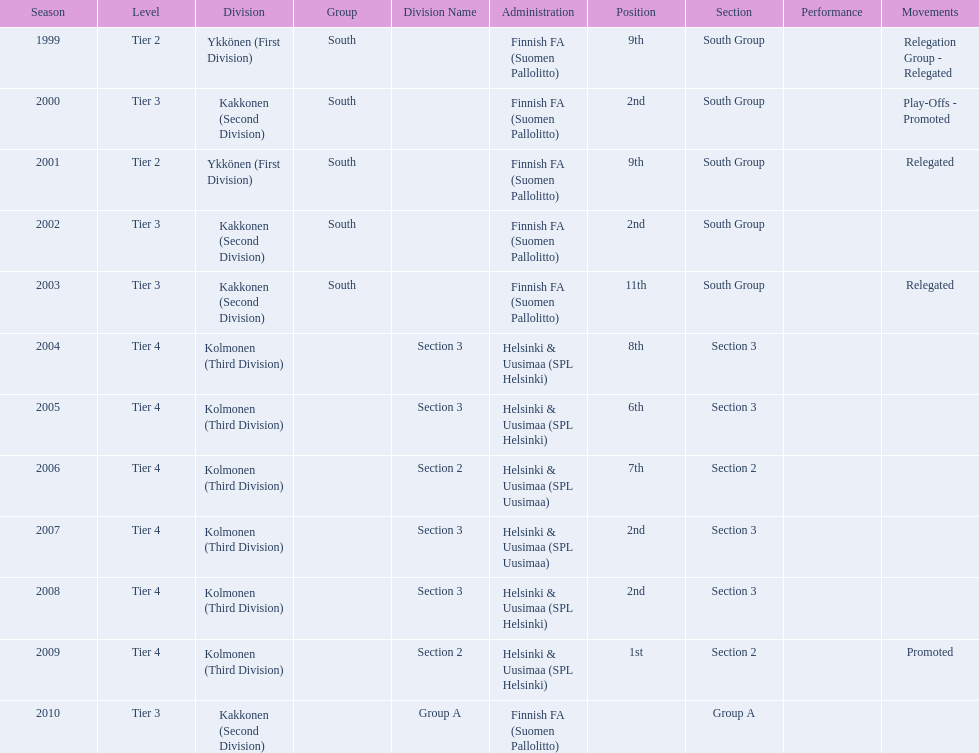Of the third division, how many were in section3? 4. 